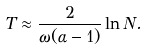Convert formula to latex. <formula><loc_0><loc_0><loc_500><loc_500>T \approx \frac { 2 } { \omega ( \alpha - 1 ) } \ln N .</formula> 